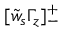<formula> <loc_0><loc_0><loc_500><loc_500>[ \tilde { w } _ { s } \Gamma _ { z } ] _ { - } ^ { + }</formula> 